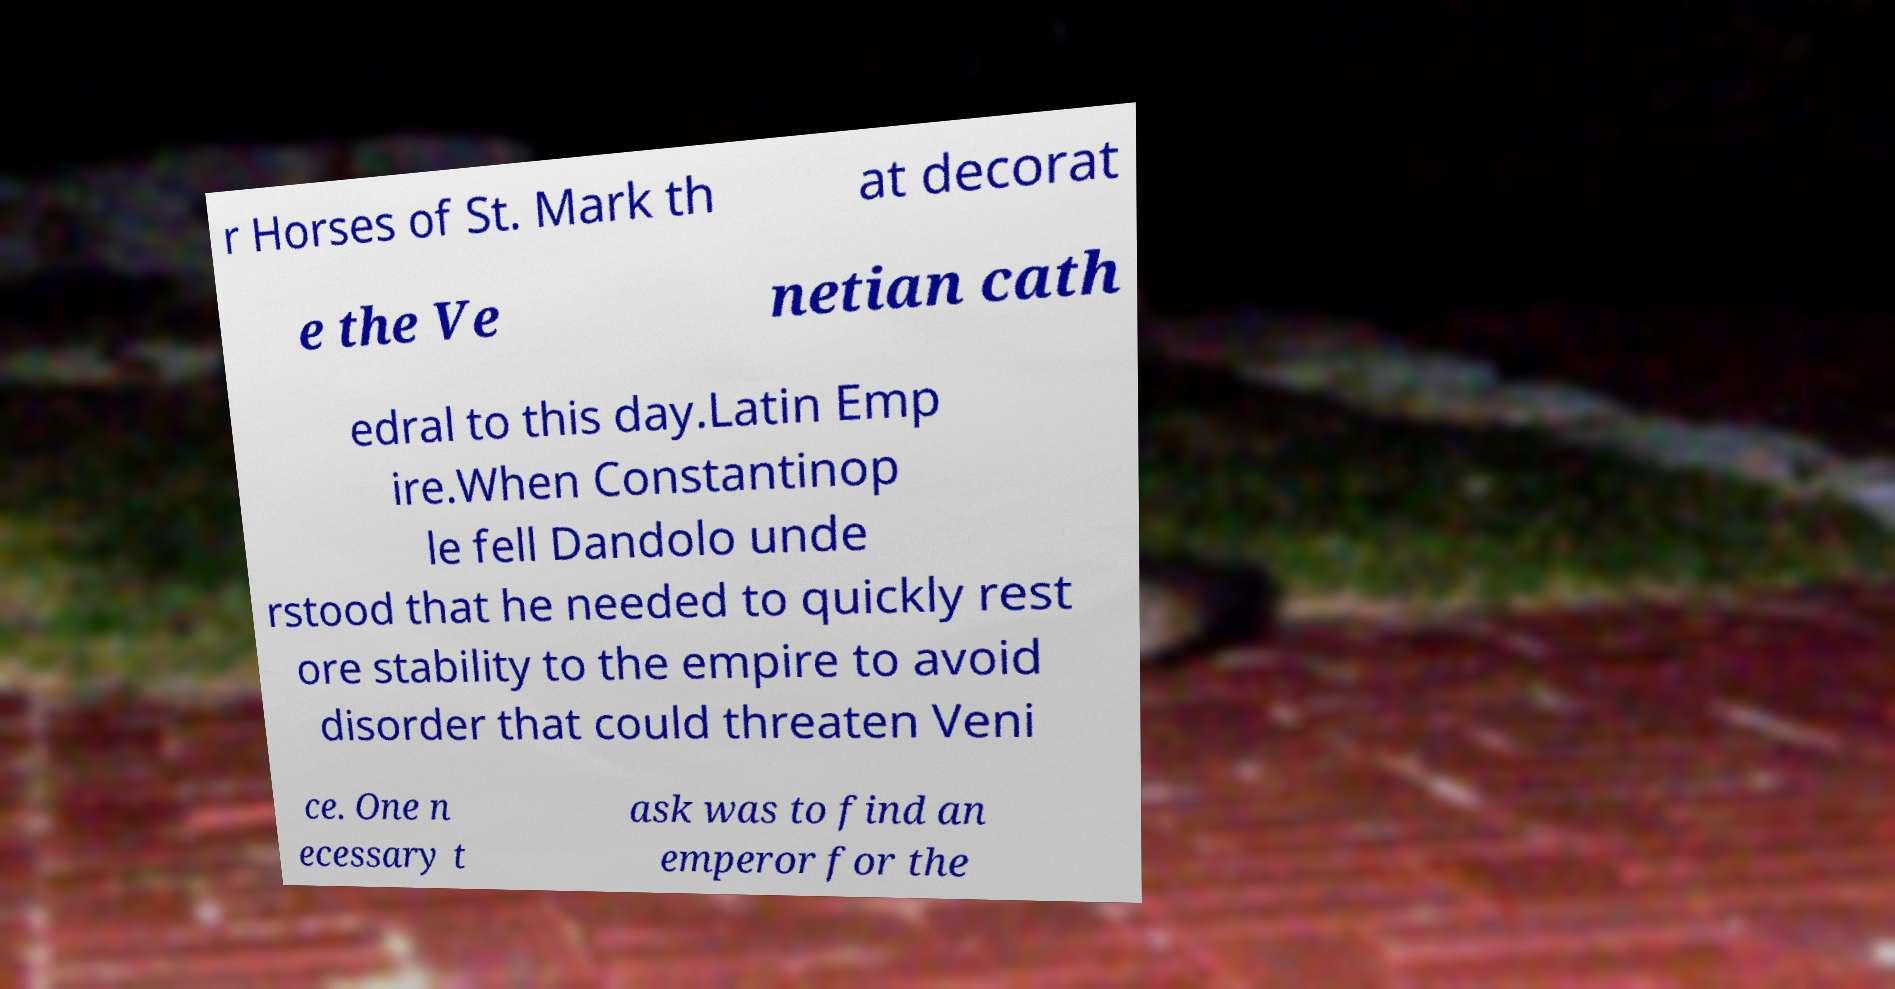Could you extract and type out the text from this image? r Horses of St. Mark th at decorat e the Ve netian cath edral to this day.Latin Emp ire.When Constantinop le fell Dandolo unde rstood that he needed to quickly rest ore stability to the empire to avoid disorder that could threaten Veni ce. One n ecessary t ask was to find an emperor for the 